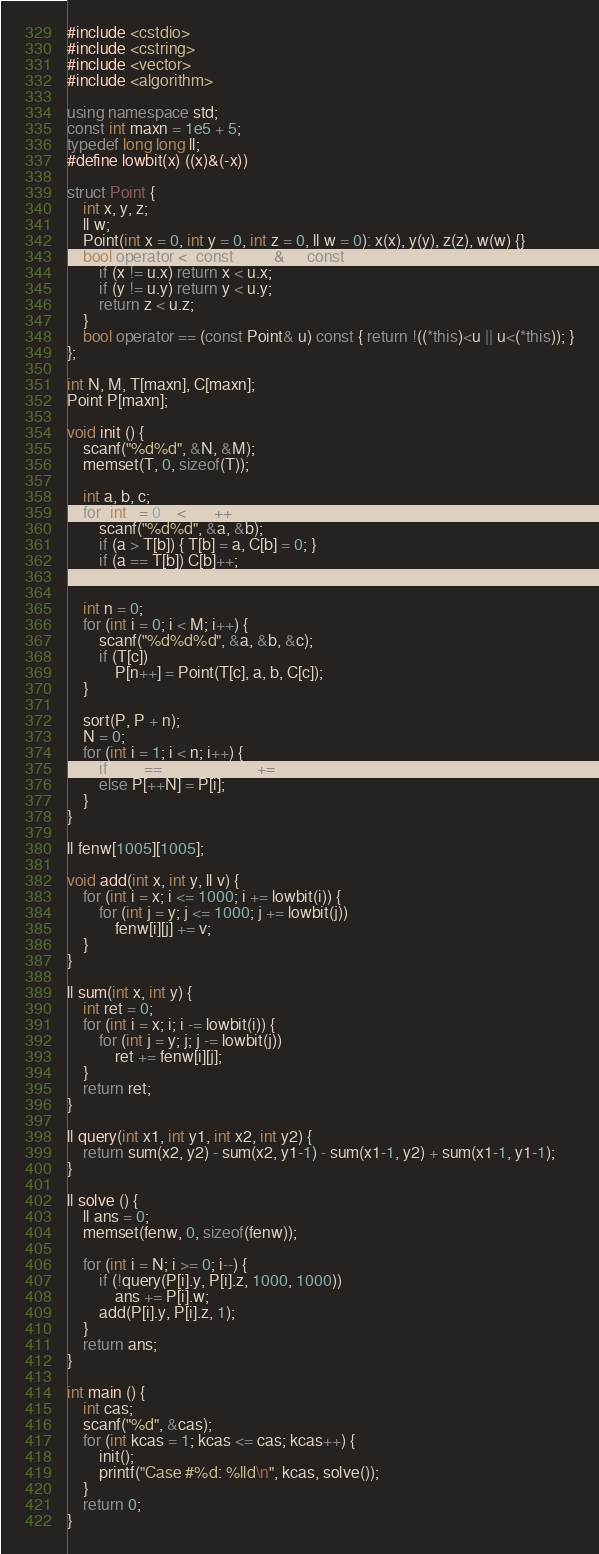Convert code to text. <code><loc_0><loc_0><loc_500><loc_500><_C++_>#include <cstdio>
#include <cstring>
#include <vector>
#include <algorithm>

using namespace std;
const int maxn = 1e5 + 5;
typedef long long ll;
#define lowbit(x) ((x)&(-x))

struct Point {
	int x, y, z;
	ll w;
	Point(int x = 0, int y = 0, int z = 0, ll w = 0): x(x), y(y), z(z), w(w) {}
	bool operator < (const Point& u) const { 
		if (x != u.x) return x < u.x;
		if (y != u.y) return y < u.y;
		return z < u.z;
	}
	bool operator == (const Point& u) const { return !((*this)<u || u<(*this)); }
};

int N, M, T[maxn], C[maxn];
Point P[maxn];

void init () {
	scanf("%d%d", &N, &M);
	memset(T, 0, sizeof(T));

	int a, b, c;
	for (int i = 0; i < N; i++) {
		scanf("%d%d", &a, &b);
		if (a > T[b]) { T[b] = a, C[b] = 0; }
		if (a == T[b]) C[b]++;
	}

	int n = 0;
	for (int i = 0; i < M; i++) {
		scanf("%d%d%d", &a, &b, &c);
		if (T[c])
			P[n++] = Point(T[c], a, b, C[c]);
	}

	sort(P, P + n);
	N = 0;
	for (int i = 1; i < n; i++) {
		if (P[i] == P[N]) P[N].w += P[i].w;
		else P[++N] = P[i];
	}
}

ll fenw[1005][1005];

void add(int x, int y, ll v) {
	for (int i = x; i <= 1000; i += lowbit(i)) {
		for (int j = y; j <= 1000; j += lowbit(j)) 
			fenw[i][j] += v;
	}
}

ll sum(int x, int y) {
	int ret = 0;
	for (int i = x; i; i -= lowbit(i)) {
		for (int j = y; j; j -= lowbit(j))
			ret += fenw[i][j];
	}
	return ret;
}

ll query(int x1, int y1, int x2, int y2) {
	return sum(x2, y2) - sum(x2, y1-1) - sum(x1-1, y2) + sum(x1-1, y1-1);
}

ll solve () {
	ll ans = 0;
	memset(fenw, 0, sizeof(fenw));

	for (int i = N; i >= 0; i--) {
		if (!query(P[i].y, P[i].z, 1000, 1000))
			ans += P[i].w;
		add(P[i].y, P[i].z, 1);
	}
	return ans;
}

int main () {
	int cas;
	scanf("%d", &cas);
	for (int kcas = 1; kcas <= cas; kcas++) {
		init();
		printf("Case #%d: %lld\n", kcas, solve());
	}
	return 0;
}
</code> 